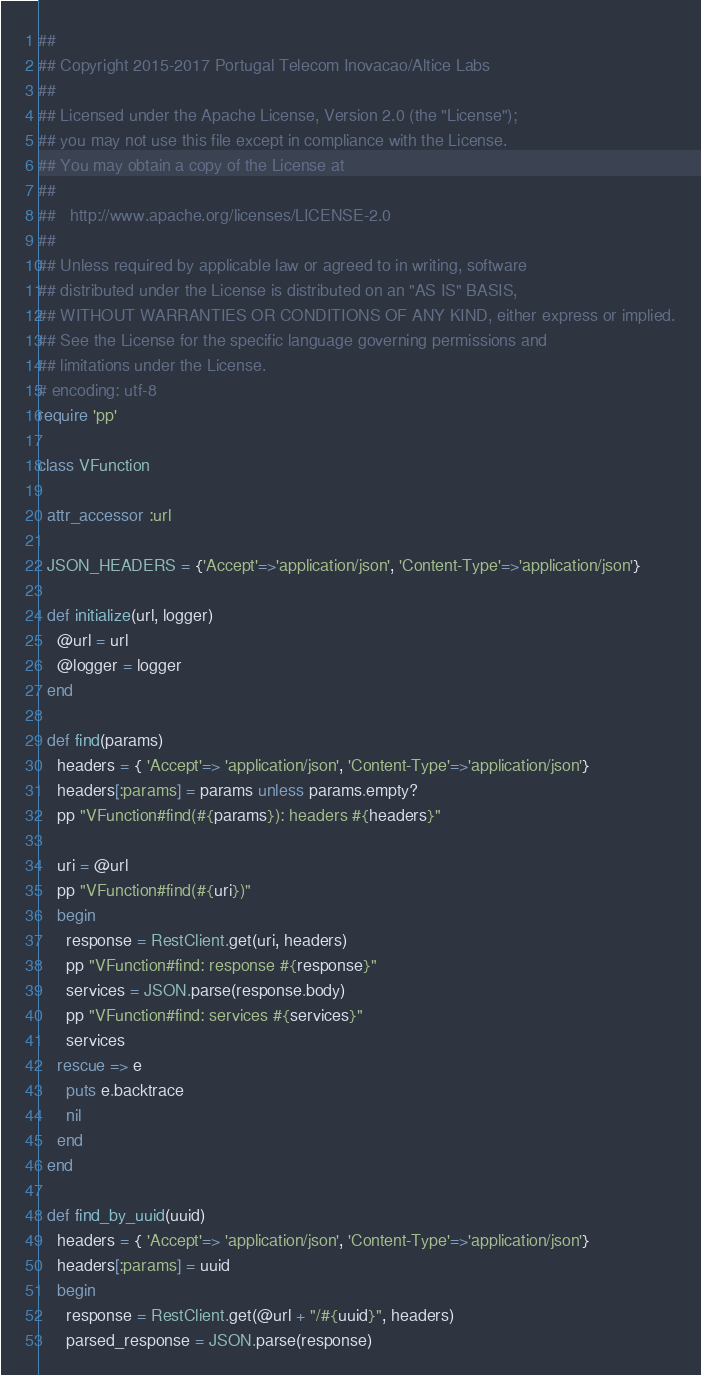Convert code to text. <code><loc_0><loc_0><loc_500><loc_500><_Ruby_>##
## Copyright 2015-2017 Portugal Telecom Inovacao/Altice Labs
##
## Licensed under the Apache License, Version 2.0 (the "License");
## you may not use this file except in compliance with the License.
## You may obtain a copy of the License at
##
##   http://www.apache.org/licenses/LICENSE-2.0
##
## Unless required by applicable law or agreed to in writing, software
## distributed under the License is distributed on an "AS IS" BASIS,
## WITHOUT WARRANTIES OR CONDITIONS OF ANY KIND, either express or implied.
## See the License for the specific language governing permissions and
## limitations under the License.
# encoding: utf-8
require 'pp'

class VFunction
  
  attr_accessor :url
  
  JSON_HEADERS = {'Accept'=>'application/json', 'Content-Type'=>'application/json'}
  
  def initialize(url, logger)
    @url = url
    @logger = logger
  end
  
  def find(params)
    headers = { 'Accept'=> 'application/json', 'Content-Type'=>'application/json'}
    headers[:params] = params unless params.empty?
    pp "VFunction#find(#{params}): headers #{headers}"

    uri = @url
    pp "VFunction#find(#{uri})"
    begin
      response = RestClient.get(uri, headers)
      pp "VFunction#find: response #{response}"
      services = JSON.parse(response.body)
      pp "VFunction#find: services #{services}"
      services
    rescue => e
      puts e.backtrace
      nil
    end
  end

  def find_by_uuid(uuid)
    headers = { 'Accept'=> 'application/json', 'Content-Type'=>'application/json'}
    headers[:params] = uuid
    begin
      response = RestClient.get(@url + "/#{uuid}", headers) 
      parsed_response = JSON.parse(response)</code> 